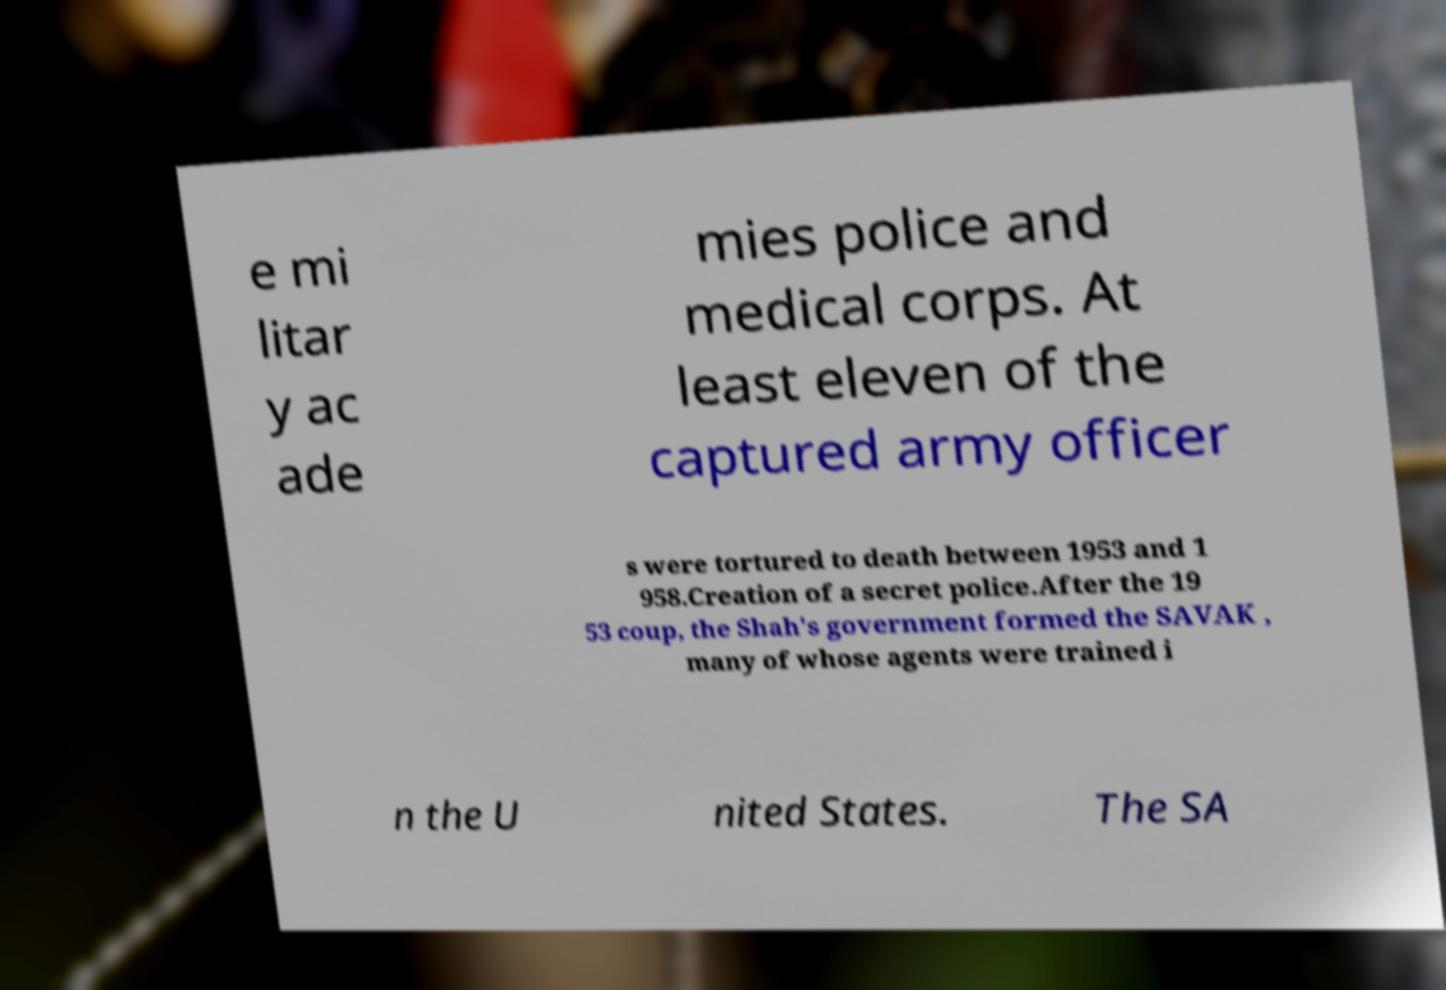I need the written content from this picture converted into text. Can you do that? e mi litar y ac ade mies police and medical corps. At least eleven of the captured army officer s were tortured to death between 1953 and 1 958.Creation of a secret police.After the 19 53 coup, the Shah's government formed the SAVAK , many of whose agents were trained i n the U nited States. The SA 